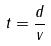<formula> <loc_0><loc_0><loc_500><loc_500>t = \frac { d } { v }</formula> 